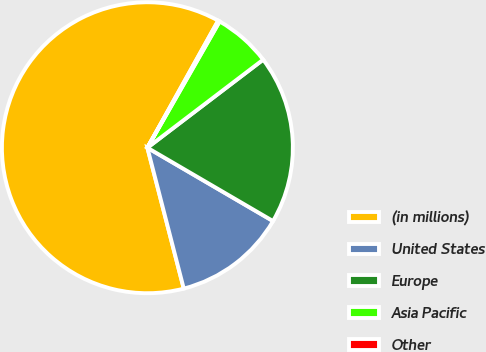<chart> <loc_0><loc_0><loc_500><loc_500><pie_chart><fcel>(in millions)<fcel>United States<fcel>Europe<fcel>Asia Pacific<fcel>Other<nl><fcel>62.11%<fcel>12.57%<fcel>18.76%<fcel>6.38%<fcel>0.18%<nl></chart> 